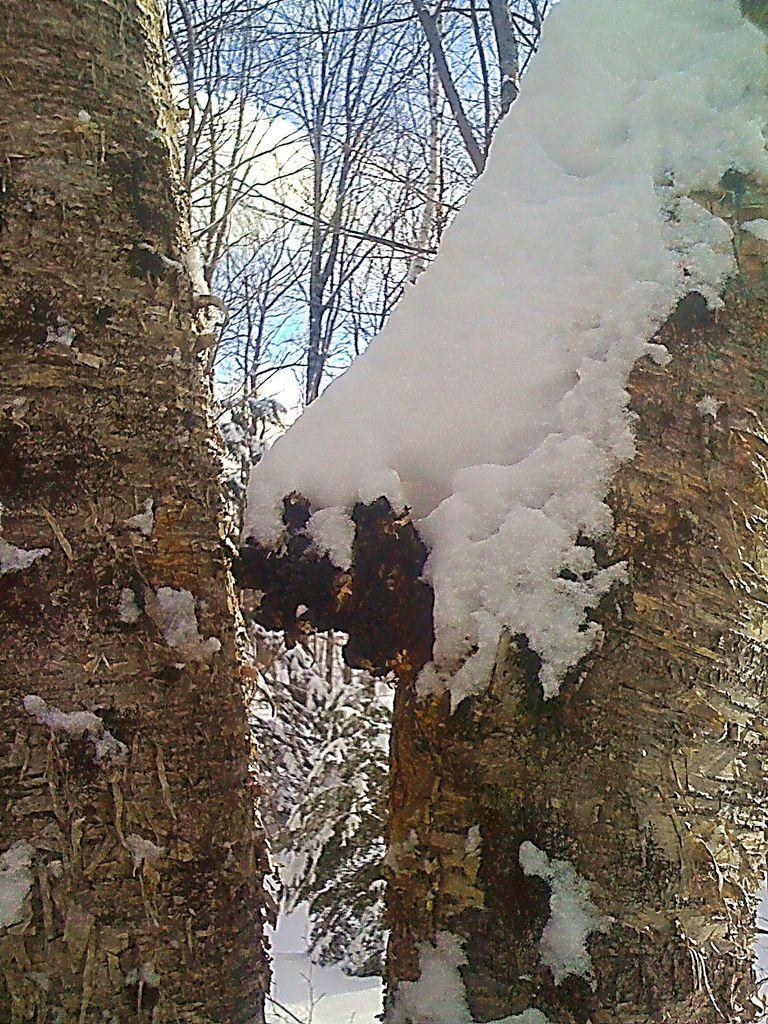What type of vegetation can be seen in the image? There are trees in the image. What is the condition of the trees in the image? The trees are covered in snow. What religion is being practiced by the trees in the image? There is no indication of any religious practice in the image, as it features trees covered in snow. 